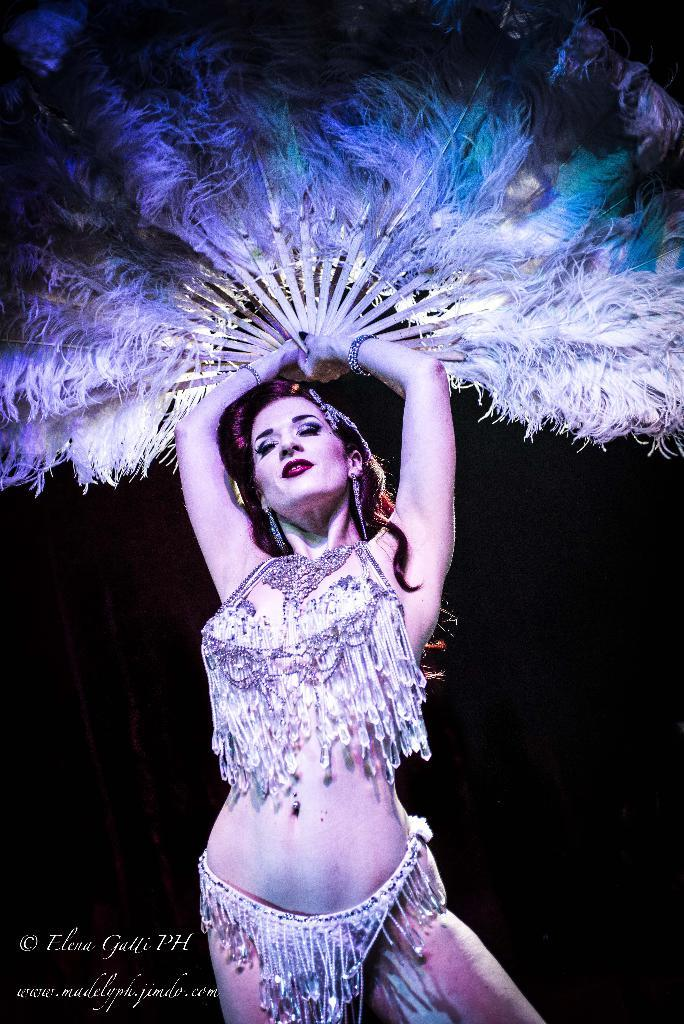Who is the main subject in the image? There is a woman in the image. What is the woman doing in the image? The woman is standing in the image. What object is the woman holding in the image? The woman is holding a feather hand fan in the image. What can be observed about the background of the image? The background of the image is dark. What type of celery can be seen in the oven in the image? There is no celery or oven present in the image. How many fish are swimming in the background of the image? There are no fish present in the image; the background is dark. 